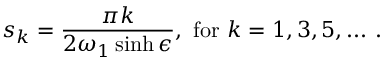Convert formula to latex. <formula><loc_0><loc_0><loc_500><loc_500>s _ { k } = \frac { \pi k } { 2 \omega _ { 1 } \sinh \epsilon } , f o r k = 1 , 3 , 5 , \dots .</formula> 